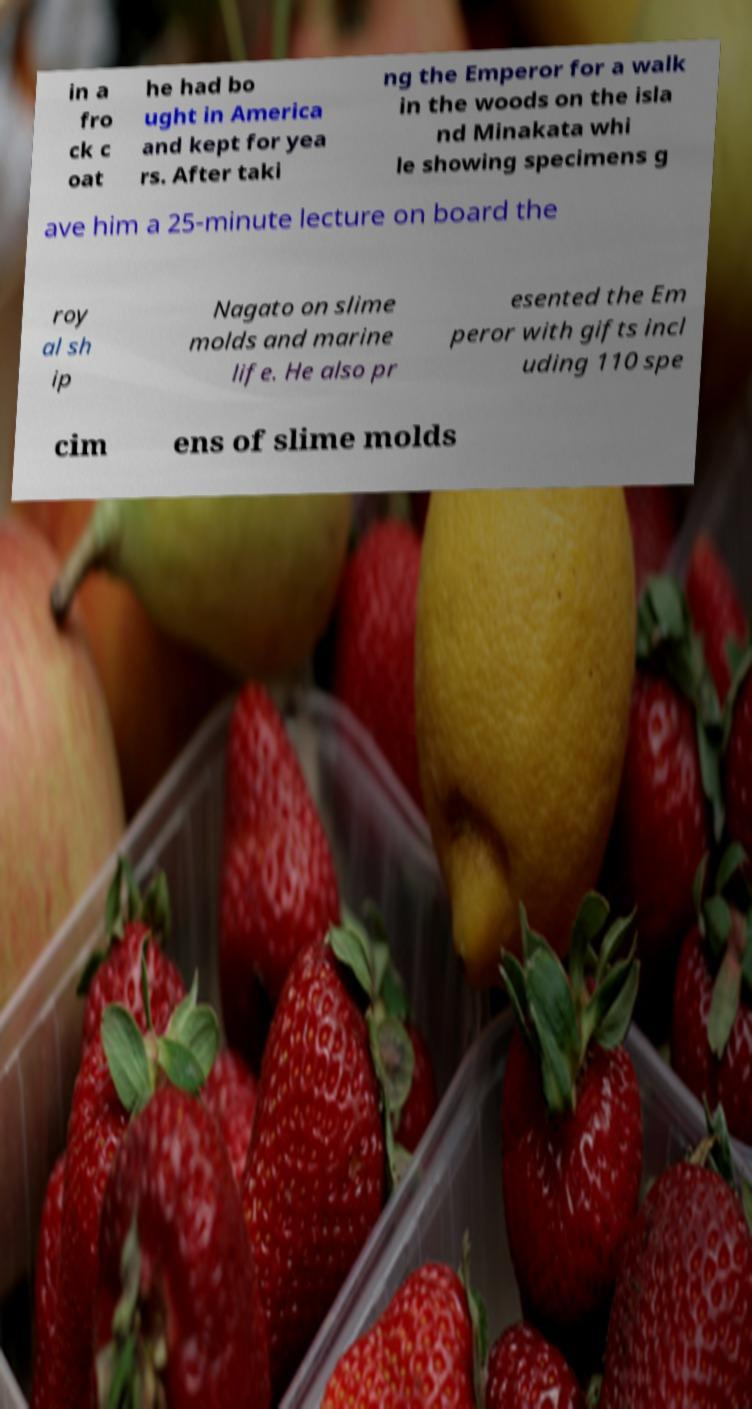Could you assist in decoding the text presented in this image and type it out clearly? in a fro ck c oat he had bo ught in America and kept for yea rs. After taki ng the Emperor for a walk in the woods on the isla nd Minakata whi le showing specimens g ave him a 25-minute lecture on board the roy al sh ip Nagato on slime molds and marine life. He also pr esented the Em peror with gifts incl uding 110 spe cim ens of slime molds 